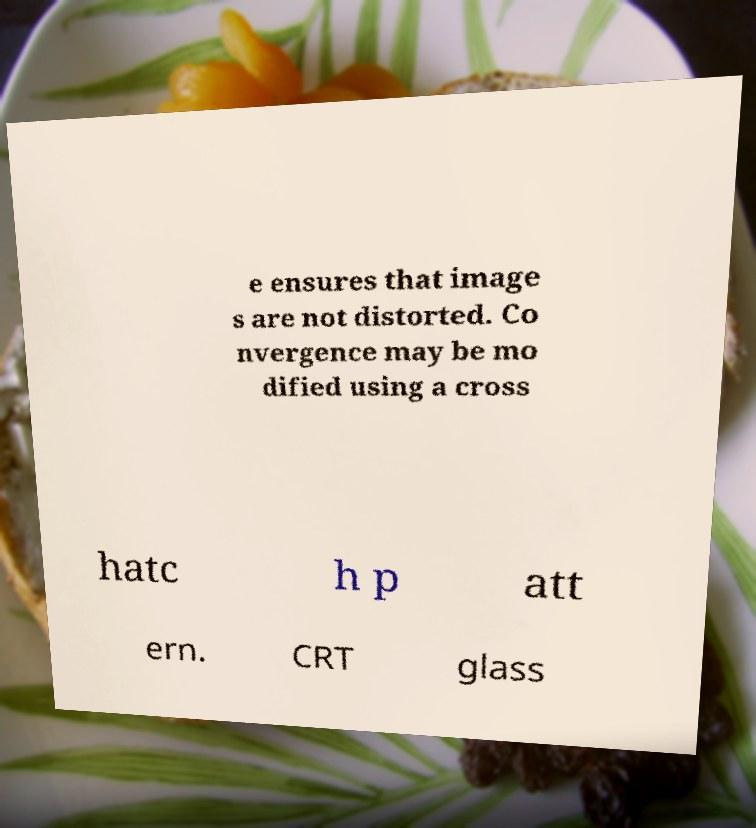Can you read and provide the text displayed in the image?This photo seems to have some interesting text. Can you extract and type it out for me? e ensures that image s are not distorted. Co nvergence may be mo dified using a cross hatc h p att ern. CRT glass 